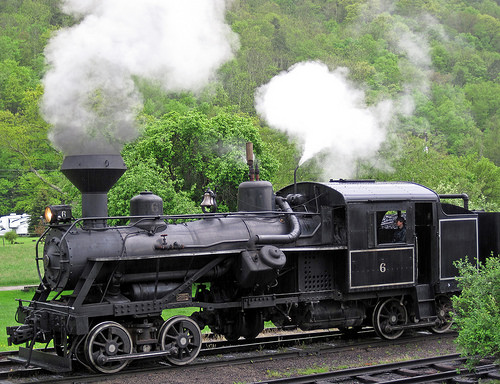<image>
Is the train in front of the bush? No. The train is not in front of the bush. The spatial positioning shows a different relationship between these objects. 